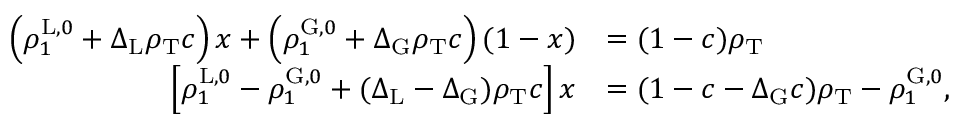Convert formula to latex. <formula><loc_0><loc_0><loc_500><loc_500>\begin{array} { r l } { \left ( \rho _ { 1 } ^ { L , 0 } + \Delta _ { L } \rho _ { T } c \right ) x + \left ( \rho _ { 1 } ^ { G , 0 } + \Delta _ { G } \rho _ { T } c \right ) ( 1 - x ) } & { = ( 1 - c ) \rho _ { T } } \\ { \left [ \rho _ { 1 } ^ { L , 0 } - \rho _ { 1 } ^ { G , 0 } + ( \Delta _ { L } - \Delta _ { G } ) \rho _ { T } c \right ] x } & { = ( 1 - c - \Delta _ { G } c ) \rho _ { T } - \rho _ { 1 } ^ { G , 0 } , } \end{array}</formula> 